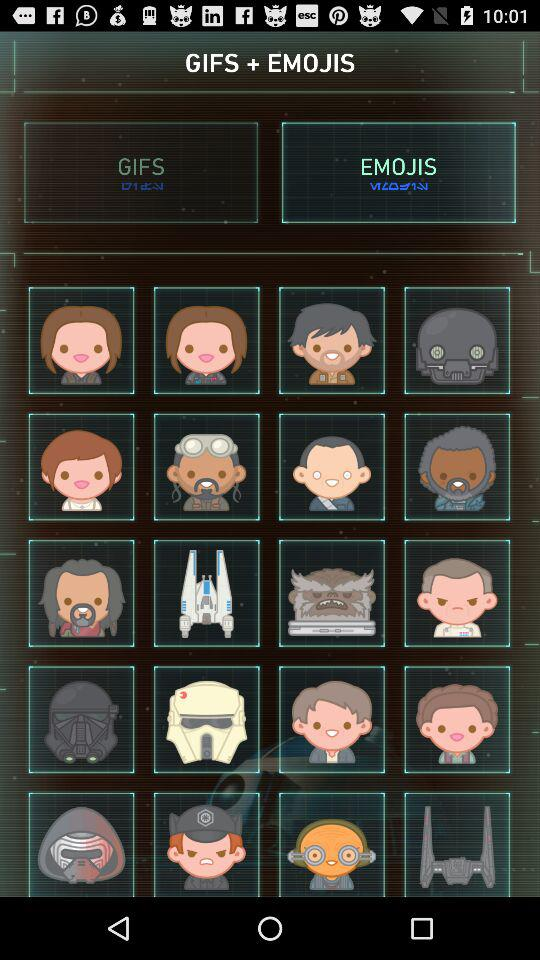What is the application name?
When the provided information is insufficient, respond with <no answer>. <no answer> 